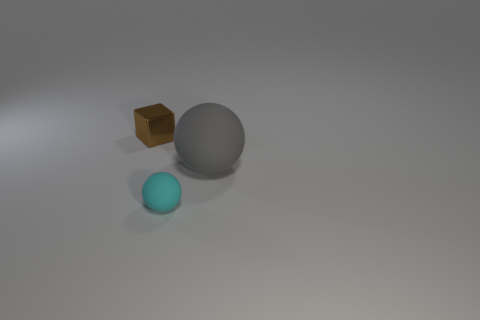Is there anything else that has the same size as the gray matte thing?
Keep it short and to the point. No. What is the color of the other object that is the same shape as the gray rubber thing?
Offer a terse response. Cyan. What is the shape of the tiny object behind the thing that is to the right of the small object that is in front of the tiny brown object?
Your answer should be compact. Cube. What size is the thing that is both to the right of the small brown metal block and behind the cyan object?
Provide a short and direct response. Large. Are there fewer gray balls than spheres?
Provide a short and direct response. Yes. There is a rubber object to the right of the cyan rubber ball; what size is it?
Offer a terse response. Large. There is a object that is behind the cyan sphere and in front of the tiny brown object; what is its shape?
Make the answer very short. Sphere. There is another thing that is the same shape as the small cyan object; what is its size?
Your response must be concise. Large. How many small brown things have the same material as the large gray thing?
Make the answer very short. 0. There is a small matte sphere; is it the same color as the tiny object behind the small rubber sphere?
Make the answer very short. No. 